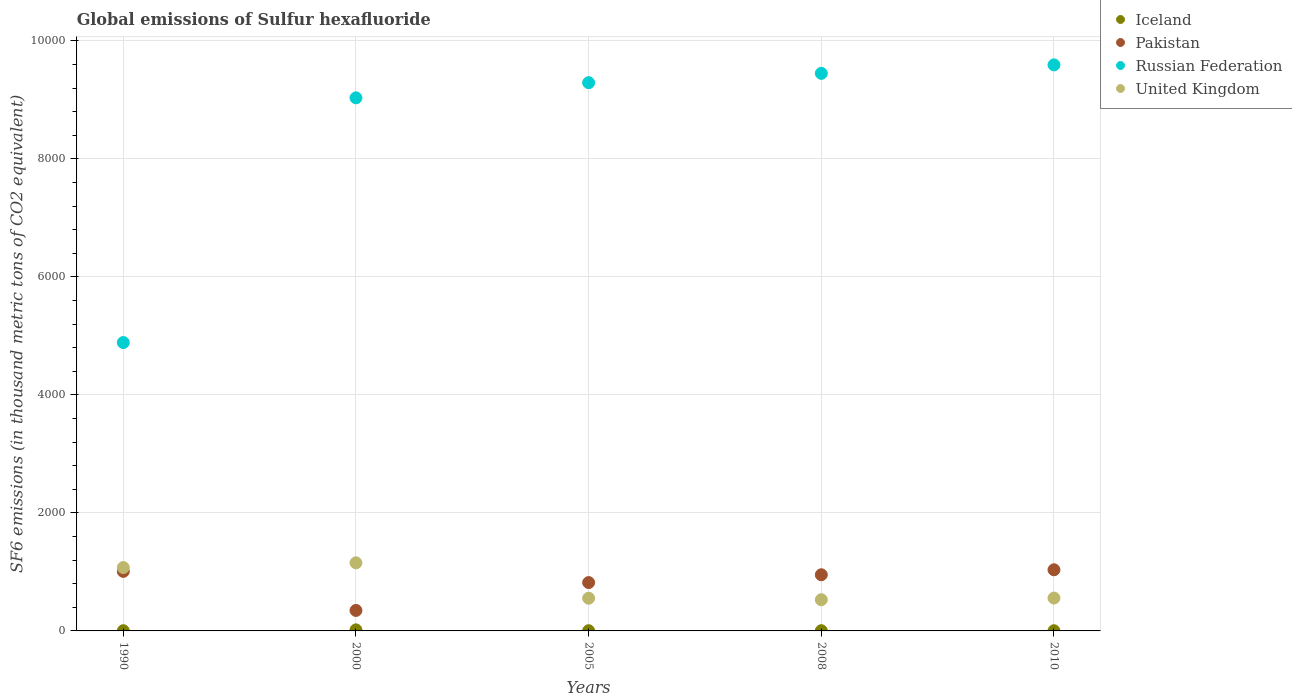Is the number of dotlines equal to the number of legend labels?
Provide a succinct answer. Yes. Across all years, what is the maximum global emissions of Sulfur hexafluoride in United Kingdom?
Offer a terse response. 1154.1. Across all years, what is the minimum global emissions of Sulfur hexafluoride in Russian Federation?
Ensure brevity in your answer.  4886.8. What is the total global emissions of Sulfur hexafluoride in United Kingdom in the graph?
Provide a succinct answer. 3868.1. What is the difference between the global emissions of Sulfur hexafluoride in United Kingdom in 2000 and that in 2008?
Provide a short and direct response. 625.2. What is the difference between the global emissions of Sulfur hexafluoride in Pakistan in 2000 and the global emissions of Sulfur hexafluoride in Russian Federation in 1990?
Make the answer very short. -4539.6. What is the average global emissions of Sulfur hexafluoride in United Kingdom per year?
Provide a short and direct response. 773.62. In the year 2005, what is the difference between the global emissions of Sulfur hexafluoride in Iceland and global emissions of Sulfur hexafluoride in Russian Federation?
Give a very brief answer. -9286.4. In how many years, is the global emissions of Sulfur hexafluoride in Iceland greater than 800 thousand metric tons?
Keep it short and to the point. 0. What is the ratio of the global emissions of Sulfur hexafluoride in United Kingdom in 2000 to that in 2005?
Make the answer very short. 2.08. Is the global emissions of Sulfur hexafluoride in Pakistan in 2005 less than that in 2008?
Make the answer very short. Yes. Is the difference between the global emissions of Sulfur hexafluoride in Iceland in 1990 and 2010 greater than the difference between the global emissions of Sulfur hexafluoride in Russian Federation in 1990 and 2010?
Offer a very short reply. Yes. What is the difference between the highest and the second highest global emissions of Sulfur hexafluoride in Iceland?
Offer a very short reply. 13.9. What is the difference between the highest and the lowest global emissions of Sulfur hexafluoride in Iceland?
Offer a very short reply. 14.9. Is the sum of the global emissions of Sulfur hexafluoride in Russian Federation in 2000 and 2008 greater than the maximum global emissions of Sulfur hexafluoride in Pakistan across all years?
Make the answer very short. Yes. Is it the case that in every year, the sum of the global emissions of Sulfur hexafluoride in Iceland and global emissions of Sulfur hexafluoride in Russian Federation  is greater than the sum of global emissions of Sulfur hexafluoride in United Kingdom and global emissions of Sulfur hexafluoride in Pakistan?
Your answer should be very brief. No. Is it the case that in every year, the sum of the global emissions of Sulfur hexafluoride in Iceland and global emissions of Sulfur hexafluoride in United Kingdom  is greater than the global emissions of Sulfur hexafluoride in Russian Federation?
Your response must be concise. No. Does the global emissions of Sulfur hexafluoride in Russian Federation monotonically increase over the years?
Provide a succinct answer. Yes. Is the global emissions of Sulfur hexafluoride in Iceland strictly greater than the global emissions of Sulfur hexafluoride in Pakistan over the years?
Provide a short and direct response. No. Is the global emissions of Sulfur hexafluoride in Russian Federation strictly less than the global emissions of Sulfur hexafluoride in Iceland over the years?
Offer a very short reply. No. How many dotlines are there?
Offer a terse response. 4. How many years are there in the graph?
Provide a short and direct response. 5. Does the graph contain grids?
Your answer should be compact. Yes. Where does the legend appear in the graph?
Provide a succinct answer. Top right. How are the legend labels stacked?
Ensure brevity in your answer.  Vertical. What is the title of the graph?
Your answer should be compact. Global emissions of Sulfur hexafluoride. What is the label or title of the X-axis?
Your response must be concise. Years. What is the label or title of the Y-axis?
Your answer should be compact. SF6 emissions (in thousand metric tons of CO2 equivalent). What is the SF6 emissions (in thousand metric tons of CO2 equivalent) in Pakistan in 1990?
Offer a terse response. 1009. What is the SF6 emissions (in thousand metric tons of CO2 equivalent) of Russian Federation in 1990?
Your answer should be very brief. 4886.8. What is the SF6 emissions (in thousand metric tons of CO2 equivalent) in United Kingdom in 1990?
Offer a terse response. 1073.9. What is the SF6 emissions (in thousand metric tons of CO2 equivalent) of Iceland in 2000?
Ensure brevity in your answer.  17.9. What is the SF6 emissions (in thousand metric tons of CO2 equivalent) in Pakistan in 2000?
Your answer should be compact. 347.2. What is the SF6 emissions (in thousand metric tons of CO2 equivalent) of Russian Federation in 2000?
Provide a short and direct response. 9033.2. What is the SF6 emissions (in thousand metric tons of CO2 equivalent) in United Kingdom in 2000?
Offer a terse response. 1154.1. What is the SF6 emissions (in thousand metric tons of CO2 equivalent) in Pakistan in 2005?
Make the answer very short. 819.4. What is the SF6 emissions (in thousand metric tons of CO2 equivalent) of Russian Federation in 2005?
Offer a very short reply. 9289.9. What is the SF6 emissions (in thousand metric tons of CO2 equivalent) in United Kingdom in 2005?
Give a very brief answer. 554.2. What is the SF6 emissions (in thousand metric tons of CO2 equivalent) of Iceland in 2008?
Keep it short and to the point. 4. What is the SF6 emissions (in thousand metric tons of CO2 equivalent) in Pakistan in 2008?
Make the answer very short. 951.6. What is the SF6 emissions (in thousand metric tons of CO2 equivalent) in Russian Federation in 2008?
Ensure brevity in your answer.  9448.2. What is the SF6 emissions (in thousand metric tons of CO2 equivalent) of United Kingdom in 2008?
Provide a short and direct response. 528.9. What is the SF6 emissions (in thousand metric tons of CO2 equivalent) of Pakistan in 2010?
Make the answer very short. 1036. What is the SF6 emissions (in thousand metric tons of CO2 equivalent) of Russian Federation in 2010?
Make the answer very short. 9592. What is the SF6 emissions (in thousand metric tons of CO2 equivalent) of United Kingdom in 2010?
Offer a very short reply. 557. Across all years, what is the maximum SF6 emissions (in thousand metric tons of CO2 equivalent) of Iceland?
Give a very brief answer. 17.9. Across all years, what is the maximum SF6 emissions (in thousand metric tons of CO2 equivalent) of Pakistan?
Offer a very short reply. 1036. Across all years, what is the maximum SF6 emissions (in thousand metric tons of CO2 equivalent) in Russian Federation?
Offer a terse response. 9592. Across all years, what is the maximum SF6 emissions (in thousand metric tons of CO2 equivalent) of United Kingdom?
Your response must be concise. 1154.1. Across all years, what is the minimum SF6 emissions (in thousand metric tons of CO2 equivalent) in Iceland?
Offer a terse response. 3. Across all years, what is the minimum SF6 emissions (in thousand metric tons of CO2 equivalent) of Pakistan?
Give a very brief answer. 347.2. Across all years, what is the minimum SF6 emissions (in thousand metric tons of CO2 equivalent) of Russian Federation?
Make the answer very short. 4886.8. Across all years, what is the minimum SF6 emissions (in thousand metric tons of CO2 equivalent) in United Kingdom?
Offer a terse response. 528.9. What is the total SF6 emissions (in thousand metric tons of CO2 equivalent) of Iceland in the graph?
Keep it short and to the point. 31.9. What is the total SF6 emissions (in thousand metric tons of CO2 equivalent) of Pakistan in the graph?
Your answer should be very brief. 4163.2. What is the total SF6 emissions (in thousand metric tons of CO2 equivalent) of Russian Federation in the graph?
Keep it short and to the point. 4.23e+04. What is the total SF6 emissions (in thousand metric tons of CO2 equivalent) of United Kingdom in the graph?
Your answer should be very brief. 3868.1. What is the difference between the SF6 emissions (in thousand metric tons of CO2 equivalent) of Iceland in 1990 and that in 2000?
Provide a succinct answer. -14.4. What is the difference between the SF6 emissions (in thousand metric tons of CO2 equivalent) in Pakistan in 1990 and that in 2000?
Your answer should be very brief. 661.8. What is the difference between the SF6 emissions (in thousand metric tons of CO2 equivalent) of Russian Federation in 1990 and that in 2000?
Provide a short and direct response. -4146.4. What is the difference between the SF6 emissions (in thousand metric tons of CO2 equivalent) of United Kingdom in 1990 and that in 2000?
Provide a succinct answer. -80.2. What is the difference between the SF6 emissions (in thousand metric tons of CO2 equivalent) in Iceland in 1990 and that in 2005?
Offer a very short reply. 0. What is the difference between the SF6 emissions (in thousand metric tons of CO2 equivalent) of Pakistan in 1990 and that in 2005?
Give a very brief answer. 189.6. What is the difference between the SF6 emissions (in thousand metric tons of CO2 equivalent) in Russian Federation in 1990 and that in 2005?
Provide a short and direct response. -4403.1. What is the difference between the SF6 emissions (in thousand metric tons of CO2 equivalent) of United Kingdom in 1990 and that in 2005?
Provide a succinct answer. 519.7. What is the difference between the SF6 emissions (in thousand metric tons of CO2 equivalent) of Iceland in 1990 and that in 2008?
Offer a very short reply. -0.5. What is the difference between the SF6 emissions (in thousand metric tons of CO2 equivalent) in Pakistan in 1990 and that in 2008?
Ensure brevity in your answer.  57.4. What is the difference between the SF6 emissions (in thousand metric tons of CO2 equivalent) of Russian Federation in 1990 and that in 2008?
Keep it short and to the point. -4561.4. What is the difference between the SF6 emissions (in thousand metric tons of CO2 equivalent) in United Kingdom in 1990 and that in 2008?
Offer a very short reply. 545. What is the difference between the SF6 emissions (in thousand metric tons of CO2 equivalent) of Iceland in 1990 and that in 2010?
Offer a very short reply. 0.5. What is the difference between the SF6 emissions (in thousand metric tons of CO2 equivalent) of Pakistan in 1990 and that in 2010?
Your answer should be very brief. -27. What is the difference between the SF6 emissions (in thousand metric tons of CO2 equivalent) of Russian Federation in 1990 and that in 2010?
Provide a short and direct response. -4705.2. What is the difference between the SF6 emissions (in thousand metric tons of CO2 equivalent) in United Kingdom in 1990 and that in 2010?
Provide a succinct answer. 516.9. What is the difference between the SF6 emissions (in thousand metric tons of CO2 equivalent) in Iceland in 2000 and that in 2005?
Your answer should be very brief. 14.4. What is the difference between the SF6 emissions (in thousand metric tons of CO2 equivalent) in Pakistan in 2000 and that in 2005?
Your answer should be compact. -472.2. What is the difference between the SF6 emissions (in thousand metric tons of CO2 equivalent) of Russian Federation in 2000 and that in 2005?
Make the answer very short. -256.7. What is the difference between the SF6 emissions (in thousand metric tons of CO2 equivalent) of United Kingdom in 2000 and that in 2005?
Give a very brief answer. 599.9. What is the difference between the SF6 emissions (in thousand metric tons of CO2 equivalent) in Iceland in 2000 and that in 2008?
Provide a short and direct response. 13.9. What is the difference between the SF6 emissions (in thousand metric tons of CO2 equivalent) in Pakistan in 2000 and that in 2008?
Provide a short and direct response. -604.4. What is the difference between the SF6 emissions (in thousand metric tons of CO2 equivalent) of Russian Federation in 2000 and that in 2008?
Your answer should be compact. -415. What is the difference between the SF6 emissions (in thousand metric tons of CO2 equivalent) of United Kingdom in 2000 and that in 2008?
Make the answer very short. 625.2. What is the difference between the SF6 emissions (in thousand metric tons of CO2 equivalent) of Pakistan in 2000 and that in 2010?
Your response must be concise. -688.8. What is the difference between the SF6 emissions (in thousand metric tons of CO2 equivalent) in Russian Federation in 2000 and that in 2010?
Give a very brief answer. -558.8. What is the difference between the SF6 emissions (in thousand metric tons of CO2 equivalent) in United Kingdom in 2000 and that in 2010?
Your answer should be compact. 597.1. What is the difference between the SF6 emissions (in thousand metric tons of CO2 equivalent) of Pakistan in 2005 and that in 2008?
Offer a very short reply. -132.2. What is the difference between the SF6 emissions (in thousand metric tons of CO2 equivalent) of Russian Federation in 2005 and that in 2008?
Offer a terse response. -158.3. What is the difference between the SF6 emissions (in thousand metric tons of CO2 equivalent) in United Kingdom in 2005 and that in 2008?
Make the answer very short. 25.3. What is the difference between the SF6 emissions (in thousand metric tons of CO2 equivalent) of Iceland in 2005 and that in 2010?
Ensure brevity in your answer.  0.5. What is the difference between the SF6 emissions (in thousand metric tons of CO2 equivalent) of Pakistan in 2005 and that in 2010?
Your response must be concise. -216.6. What is the difference between the SF6 emissions (in thousand metric tons of CO2 equivalent) of Russian Federation in 2005 and that in 2010?
Provide a succinct answer. -302.1. What is the difference between the SF6 emissions (in thousand metric tons of CO2 equivalent) in United Kingdom in 2005 and that in 2010?
Your response must be concise. -2.8. What is the difference between the SF6 emissions (in thousand metric tons of CO2 equivalent) of Pakistan in 2008 and that in 2010?
Your response must be concise. -84.4. What is the difference between the SF6 emissions (in thousand metric tons of CO2 equivalent) in Russian Federation in 2008 and that in 2010?
Make the answer very short. -143.8. What is the difference between the SF6 emissions (in thousand metric tons of CO2 equivalent) of United Kingdom in 2008 and that in 2010?
Offer a terse response. -28.1. What is the difference between the SF6 emissions (in thousand metric tons of CO2 equivalent) of Iceland in 1990 and the SF6 emissions (in thousand metric tons of CO2 equivalent) of Pakistan in 2000?
Keep it short and to the point. -343.7. What is the difference between the SF6 emissions (in thousand metric tons of CO2 equivalent) in Iceland in 1990 and the SF6 emissions (in thousand metric tons of CO2 equivalent) in Russian Federation in 2000?
Your answer should be very brief. -9029.7. What is the difference between the SF6 emissions (in thousand metric tons of CO2 equivalent) of Iceland in 1990 and the SF6 emissions (in thousand metric tons of CO2 equivalent) of United Kingdom in 2000?
Keep it short and to the point. -1150.6. What is the difference between the SF6 emissions (in thousand metric tons of CO2 equivalent) in Pakistan in 1990 and the SF6 emissions (in thousand metric tons of CO2 equivalent) in Russian Federation in 2000?
Your answer should be compact. -8024.2. What is the difference between the SF6 emissions (in thousand metric tons of CO2 equivalent) of Pakistan in 1990 and the SF6 emissions (in thousand metric tons of CO2 equivalent) of United Kingdom in 2000?
Provide a short and direct response. -145.1. What is the difference between the SF6 emissions (in thousand metric tons of CO2 equivalent) in Russian Federation in 1990 and the SF6 emissions (in thousand metric tons of CO2 equivalent) in United Kingdom in 2000?
Your answer should be compact. 3732.7. What is the difference between the SF6 emissions (in thousand metric tons of CO2 equivalent) of Iceland in 1990 and the SF6 emissions (in thousand metric tons of CO2 equivalent) of Pakistan in 2005?
Offer a terse response. -815.9. What is the difference between the SF6 emissions (in thousand metric tons of CO2 equivalent) of Iceland in 1990 and the SF6 emissions (in thousand metric tons of CO2 equivalent) of Russian Federation in 2005?
Your answer should be very brief. -9286.4. What is the difference between the SF6 emissions (in thousand metric tons of CO2 equivalent) in Iceland in 1990 and the SF6 emissions (in thousand metric tons of CO2 equivalent) in United Kingdom in 2005?
Offer a terse response. -550.7. What is the difference between the SF6 emissions (in thousand metric tons of CO2 equivalent) in Pakistan in 1990 and the SF6 emissions (in thousand metric tons of CO2 equivalent) in Russian Federation in 2005?
Offer a very short reply. -8280.9. What is the difference between the SF6 emissions (in thousand metric tons of CO2 equivalent) of Pakistan in 1990 and the SF6 emissions (in thousand metric tons of CO2 equivalent) of United Kingdom in 2005?
Give a very brief answer. 454.8. What is the difference between the SF6 emissions (in thousand metric tons of CO2 equivalent) in Russian Federation in 1990 and the SF6 emissions (in thousand metric tons of CO2 equivalent) in United Kingdom in 2005?
Your answer should be compact. 4332.6. What is the difference between the SF6 emissions (in thousand metric tons of CO2 equivalent) in Iceland in 1990 and the SF6 emissions (in thousand metric tons of CO2 equivalent) in Pakistan in 2008?
Give a very brief answer. -948.1. What is the difference between the SF6 emissions (in thousand metric tons of CO2 equivalent) of Iceland in 1990 and the SF6 emissions (in thousand metric tons of CO2 equivalent) of Russian Federation in 2008?
Your answer should be compact. -9444.7. What is the difference between the SF6 emissions (in thousand metric tons of CO2 equivalent) in Iceland in 1990 and the SF6 emissions (in thousand metric tons of CO2 equivalent) in United Kingdom in 2008?
Your answer should be very brief. -525.4. What is the difference between the SF6 emissions (in thousand metric tons of CO2 equivalent) in Pakistan in 1990 and the SF6 emissions (in thousand metric tons of CO2 equivalent) in Russian Federation in 2008?
Offer a very short reply. -8439.2. What is the difference between the SF6 emissions (in thousand metric tons of CO2 equivalent) in Pakistan in 1990 and the SF6 emissions (in thousand metric tons of CO2 equivalent) in United Kingdom in 2008?
Provide a short and direct response. 480.1. What is the difference between the SF6 emissions (in thousand metric tons of CO2 equivalent) of Russian Federation in 1990 and the SF6 emissions (in thousand metric tons of CO2 equivalent) of United Kingdom in 2008?
Ensure brevity in your answer.  4357.9. What is the difference between the SF6 emissions (in thousand metric tons of CO2 equivalent) in Iceland in 1990 and the SF6 emissions (in thousand metric tons of CO2 equivalent) in Pakistan in 2010?
Make the answer very short. -1032.5. What is the difference between the SF6 emissions (in thousand metric tons of CO2 equivalent) in Iceland in 1990 and the SF6 emissions (in thousand metric tons of CO2 equivalent) in Russian Federation in 2010?
Your response must be concise. -9588.5. What is the difference between the SF6 emissions (in thousand metric tons of CO2 equivalent) in Iceland in 1990 and the SF6 emissions (in thousand metric tons of CO2 equivalent) in United Kingdom in 2010?
Offer a very short reply. -553.5. What is the difference between the SF6 emissions (in thousand metric tons of CO2 equivalent) of Pakistan in 1990 and the SF6 emissions (in thousand metric tons of CO2 equivalent) of Russian Federation in 2010?
Your answer should be very brief. -8583. What is the difference between the SF6 emissions (in thousand metric tons of CO2 equivalent) in Pakistan in 1990 and the SF6 emissions (in thousand metric tons of CO2 equivalent) in United Kingdom in 2010?
Make the answer very short. 452. What is the difference between the SF6 emissions (in thousand metric tons of CO2 equivalent) in Russian Federation in 1990 and the SF6 emissions (in thousand metric tons of CO2 equivalent) in United Kingdom in 2010?
Ensure brevity in your answer.  4329.8. What is the difference between the SF6 emissions (in thousand metric tons of CO2 equivalent) of Iceland in 2000 and the SF6 emissions (in thousand metric tons of CO2 equivalent) of Pakistan in 2005?
Your answer should be very brief. -801.5. What is the difference between the SF6 emissions (in thousand metric tons of CO2 equivalent) in Iceland in 2000 and the SF6 emissions (in thousand metric tons of CO2 equivalent) in Russian Federation in 2005?
Your response must be concise. -9272. What is the difference between the SF6 emissions (in thousand metric tons of CO2 equivalent) of Iceland in 2000 and the SF6 emissions (in thousand metric tons of CO2 equivalent) of United Kingdom in 2005?
Make the answer very short. -536.3. What is the difference between the SF6 emissions (in thousand metric tons of CO2 equivalent) of Pakistan in 2000 and the SF6 emissions (in thousand metric tons of CO2 equivalent) of Russian Federation in 2005?
Your answer should be very brief. -8942.7. What is the difference between the SF6 emissions (in thousand metric tons of CO2 equivalent) of Pakistan in 2000 and the SF6 emissions (in thousand metric tons of CO2 equivalent) of United Kingdom in 2005?
Offer a very short reply. -207. What is the difference between the SF6 emissions (in thousand metric tons of CO2 equivalent) in Russian Federation in 2000 and the SF6 emissions (in thousand metric tons of CO2 equivalent) in United Kingdom in 2005?
Your response must be concise. 8479. What is the difference between the SF6 emissions (in thousand metric tons of CO2 equivalent) in Iceland in 2000 and the SF6 emissions (in thousand metric tons of CO2 equivalent) in Pakistan in 2008?
Your response must be concise. -933.7. What is the difference between the SF6 emissions (in thousand metric tons of CO2 equivalent) of Iceland in 2000 and the SF6 emissions (in thousand metric tons of CO2 equivalent) of Russian Federation in 2008?
Ensure brevity in your answer.  -9430.3. What is the difference between the SF6 emissions (in thousand metric tons of CO2 equivalent) of Iceland in 2000 and the SF6 emissions (in thousand metric tons of CO2 equivalent) of United Kingdom in 2008?
Make the answer very short. -511. What is the difference between the SF6 emissions (in thousand metric tons of CO2 equivalent) of Pakistan in 2000 and the SF6 emissions (in thousand metric tons of CO2 equivalent) of Russian Federation in 2008?
Keep it short and to the point. -9101. What is the difference between the SF6 emissions (in thousand metric tons of CO2 equivalent) in Pakistan in 2000 and the SF6 emissions (in thousand metric tons of CO2 equivalent) in United Kingdom in 2008?
Offer a very short reply. -181.7. What is the difference between the SF6 emissions (in thousand metric tons of CO2 equivalent) of Russian Federation in 2000 and the SF6 emissions (in thousand metric tons of CO2 equivalent) of United Kingdom in 2008?
Ensure brevity in your answer.  8504.3. What is the difference between the SF6 emissions (in thousand metric tons of CO2 equivalent) in Iceland in 2000 and the SF6 emissions (in thousand metric tons of CO2 equivalent) in Pakistan in 2010?
Your answer should be very brief. -1018.1. What is the difference between the SF6 emissions (in thousand metric tons of CO2 equivalent) in Iceland in 2000 and the SF6 emissions (in thousand metric tons of CO2 equivalent) in Russian Federation in 2010?
Ensure brevity in your answer.  -9574.1. What is the difference between the SF6 emissions (in thousand metric tons of CO2 equivalent) in Iceland in 2000 and the SF6 emissions (in thousand metric tons of CO2 equivalent) in United Kingdom in 2010?
Your response must be concise. -539.1. What is the difference between the SF6 emissions (in thousand metric tons of CO2 equivalent) of Pakistan in 2000 and the SF6 emissions (in thousand metric tons of CO2 equivalent) of Russian Federation in 2010?
Provide a short and direct response. -9244.8. What is the difference between the SF6 emissions (in thousand metric tons of CO2 equivalent) in Pakistan in 2000 and the SF6 emissions (in thousand metric tons of CO2 equivalent) in United Kingdom in 2010?
Your response must be concise. -209.8. What is the difference between the SF6 emissions (in thousand metric tons of CO2 equivalent) of Russian Federation in 2000 and the SF6 emissions (in thousand metric tons of CO2 equivalent) of United Kingdom in 2010?
Offer a terse response. 8476.2. What is the difference between the SF6 emissions (in thousand metric tons of CO2 equivalent) of Iceland in 2005 and the SF6 emissions (in thousand metric tons of CO2 equivalent) of Pakistan in 2008?
Make the answer very short. -948.1. What is the difference between the SF6 emissions (in thousand metric tons of CO2 equivalent) in Iceland in 2005 and the SF6 emissions (in thousand metric tons of CO2 equivalent) in Russian Federation in 2008?
Provide a succinct answer. -9444.7. What is the difference between the SF6 emissions (in thousand metric tons of CO2 equivalent) in Iceland in 2005 and the SF6 emissions (in thousand metric tons of CO2 equivalent) in United Kingdom in 2008?
Keep it short and to the point. -525.4. What is the difference between the SF6 emissions (in thousand metric tons of CO2 equivalent) in Pakistan in 2005 and the SF6 emissions (in thousand metric tons of CO2 equivalent) in Russian Federation in 2008?
Provide a short and direct response. -8628.8. What is the difference between the SF6 emissions (in thousand metric tons of CO2 equivalent) in Pakistan in 2005 and the SF6 emissions (in thousand metric tons of CO2 equivalent) in United Kingdom in 2008?
Give a very brief answer. 290.5. What is the difference between the SF6 emissions (in thousand metric tons of CO2 equivalent) of Russian Federation in 2005 and the SF6 emissions (in thousand metric tons of CO2 equivalent) of United Kingdom in 2008?
Ensure brevity in your answer.  8761. What is the difference between the SF6 emissions (in thousand metric tons of CO2 equivalent) in Iceland in 2005 and the SF6 emissions (in thousand metric tons of CO2 equivalent) in Pakistan in 2010?
Offer a very short reply. -1032.5. What is the difference between the SF6 emissions (in thousand metric tons of CO2 equivalent) of Iceland in 2005 and the SF6 emissions (in thousand metric tons of CO2 equivalent) of Russian Federation in 2010?
Your answer should be compact. -9588.5. What is the difference between the SF6 emissions (in thousand metric tons of CO2 equivalent) of Iceland in 2005 and the SF6 emissions (in thousand metric tons of CO2 equivalent) of United Kingdom in 2010?
Offer a very short reply. -553.5. What is the difference between the SF6 emissions (in thousand metric tons of CO2 equivalent) of Pakistan in 2005 and the SF6 emissions (in thousand metric tons of CO2 equivalent) of Russian Federation in 2010?
Keep it short and to the point. -8772.6. What is the difference between the SF6 emissions (in thousand metric tons of CO2 equivalent) of Pakistan in 2005 and the SF6 emissions (in thousand metric tons of CO2 equivalent) of United Kingdom in 2010?
Keep it short and to the point. 262.4. What is the difference between the SF6 emissions (in thousand metric tons of CO2 equivalent) of Russian Federation in 2005 and the SF6 emissions (in thousand metric tons of CO2 equivalent) of United Kingdom in 2010?
Keep it short and to the point. 8732.9. What is the difference between the SF6 emissions (in thousand metric tons of CO2 equivalent) in Iceland in 2008 and the SF6 emissions (in thousand metric tons of CO2 equivalent) in Pakistan in 2010?
Provide a succinct answer. -1032. What is the difference between the SF6 emissions (in thousand metric tons of CO2 equivalent) of Iceland in 2008 and the SF6 emissions (in thousand metric tons of CO2 equivalent) of Russian Federation in 2010?
Your answer should be compact. -9588. What is the difference between the SF6 emissions (in thousand metric tons of CO2 equivalent) of Iceland in 2008 and the SF6 emissions (in thousand metric tons of CO2 equivalent) of United Kingdom in 2010?
Offer a very short reply. -553. What is the difference between the SF6 emissions (in thousand metric tons of CO2 equivalent) of Pakistan in 2008 and the SF6 emissions (in thousand metric tons of CO2 equivalent) of Russian Federation in 2010?
Make the answer very short. -8640.4. What is the difference between the SF6 emissions (in thousand metric tons of CO2 equivalent) in Pakistan in 2008 and the SF6 emissions (in thousand metric tons of CO2 equivalent) in United Kingdom in 2010?
Give a very brief answer. 394.6. What is the difference between the SF6 emissions (in thousand metric tons of CO2 equivalent) of Russian Federation in 2008 and the SF6 emissions (in thousand metric tons of CO2 equivalent) of United Kingdom in 2010?
Offer a terse response. 8891.2. What is the average SF6 emissions (in thousand metric tons of CO2 equivalent) in Iceland per year?
Offer a very short reply. 6.38. What is the average SF6 emissions (in thousand metric tons of CO2 equivalent) in Pakistan per year?
Provide a succinct answer. 832.64. What is the average SF6 emissions (in thousand metric tons of CO2 equivalent) of Russian Federation per year?
Offer a terse response. 8450.02. What is the average SF6 emissions (in thousand metric tons of CO2 equivalent) of United Kingdom per year?
Offer a very short reply. 773.62. In the year 1990, what is the difference between the SF6 emissions (in thousand metric tons of CO2 equivalent) in Iceland and SF6 emissions (in thousand metric tons of CO2 equivalent) in Pakistan?
Provide a succinct answer. -1005.5. In the year 1990, what is the difference between the SF6 emissions (in thousand metric tons of CO2 equivalent) of Iceland and SF6 emissions (in thousand metric tons of CO2 equivalent) of Russian Federation?
Your response must be concise. -4883.3. In the year 1990, what is the difference between the SF6 emissions (in thousand metric tons of CO2 equivalent) in Iceland and SF6 emissions (in thousand metric tons of CO2 equivalent) in United Kingdom?
Offer a very short reply. -1070.4. In the year 1990, what is the difference between the SF6 emissions (in thousand metric tons of CO2 equivalent) of Pakistan and SF6 emissions (in thousand metric tons of CO2 equivalent) of Russian Federation?
Offer a terse response. -3877.8. In the year 1990, what is the difference between the SF6 emissions (in thousand metric tons of CO2 equivalent) of Pakistan and SF6 emissions (in thousand metric tons of CO2 equivalent) of United Kingdom?
Provide a succinct answer. -64.9. In the year 1990, what is the difference between the SF6 emissions (in thousand metric tons of CO2 equivalent) of Russian Federation and SF6 emissions (in thousand metric tons of CO2 equivalent) of United Kingdom?
Your answer should be compact. 3812.9. In the year 2000, what is the difference between the SF6 emissions (in thousand metric tons of CO2 equivalent) in Iceland and SF6 emissions (in thousand metric tons of CO2 equivalent) in Pakistan?
Your answer should be very brief. -329.3. In the year 2000, what is the difference between the SF6 emissions (in thousand metric tons of CO2 equivalent) of Iceland and SF6 emissions (in thousand metric tons of CO2 equivalent) of Russian Federation?
Keep it short and to the point. -9015.3. In the year 2000, what is the difference between the SF6 emissions (in thousand metric tons of CO2 equivalent) in Iceland and SF6 emissions (in thousand metric tons of CO2 equivalent) in United Kingdom?
Your response must be concise. -1136.2. In the year 2000, what is the difference between the SF6 emissions (in thousand metric tons of CO2 equivalent) of Pakistan and SF6 emissions (in thousand metric tons of CO2 equivalent) of Russian Federation?
Ensure brevity in your answer.  -8686. In the year 2000, what is the difference between the SF6 emissions (in thousand metric tons of CO2 equivalent) in Pakistan and SF6 emissions (in thousand metric tons of CO2 equivalent) in United Kingdom?
Provide a succinct answer. -806.9. In the year 2000, what is the difference between the SF6 emissions (in thousand metric tons of CO2 equivalent) in Russian Federation and SF6 emissions (in thousand metric tons of CO2 equivalent) in United Kingdom?
Provide a short and direct response. 7879.1. In the year 2005, what is the difference between the SF6 emissions (in thousand metric tons of CO2 equivalent) of Iceland and SF6 emissions (in thousand metric tons of CO2 equivalent) of Pakistan?
Make the answer very short. -815.9. In the year 2005, what is the difference between the SF6 emissions (in thousand metric tons of CO2 equivalent) of Iceland and SF6 emissions (in thousand metric tons of CO2 equivalent) of Russian Federation?
Offer a very short reply. -9286.4. In the year 2005, what is the difference between the SF6 emissions (in thousand metric tons of CO2 equivalent) of Iceland and SF6 emissions (in thousand metric tons of CO2 equivalent) of United Kingdom?
Your response must be concise. -550.7. In the year 2005, what is the difference between the SF6 emissions (in thousand metric tons of CO2 equivalent) of Pakistan and SF6 emissions (in thousand metric tons of CO2 equivalent) of Russian Federation?
Provide a succinct answer. -8470.5. In the year 2005, what is the difference between the SF6 emissions (in thousand metric tons of CO2 equivalent) in Pakistan and SF6 emissions (in thousand metric tons of CO2 equivalent) in United Kingdom?
Provide a succinct answer. 265.2. In the year 2005, what is the difference between the SF6 emissions (in thousand metric tons of CO2 equivalent) of Russian Federation and SF6 emissions (in thousand metric tons of CO2 equivalent) of United Kingdom?
Your answer should be compact. 8735.7. In the year 2008, what is the difference between the SF6 emissions (in thousand metric tons of CO2 equivalent) of Iceland and SF6 emissions (in thousand metric tons of CO2 equivalent) of Pakistan?
Ensure brevity in your answer.  -947.6. In the year 2008, what is the difference between the SF6 emissions (in thousand metric tons of CO2 equivalent) in Iceland and SF6 emissions (in thousand metric tons of CO2 equivalent) in Russian Federation?
Give a very brief answer. -9444.2. In the year 2008, what is the difference between the SF6 emissions (in thousand metric tons of CO2 equivalent) in Iceland and SF6 emissions (in thousand metric tons of CO2 equivalent) in United Kingdom?
Give a very brief answer. -524.9. In the year 2008, what is the difference between the SF6 emissions (in thousand metric tons of CO2 equivalent) in Pakistan and SF6 emissions (in thousand metric tons of CO2 equivalent) in Russian Federation?
Provide a short and direct response. -8496.6. In the year 2008, what is the difference between the SF6 emissions (in thousand metric tons of CO2 equivalent) of Pakistan and SF6 emissions (in thousand metric tons of CO2 equivalent) of United Kingdom?
Offer a terse response. 422.7. In the year 2008, what is the difference between the SF6 emissions (in thousand metric tons of CO2 equivalent) of Russian Federation and SF6 emissions (in thousand metric tons of CO2 equivalent) of United Kingdom?
Offer a very short reply. 8919.3. In the year 2010, what is the difference between the SF6 emissions (in thousand metric tons of CO2 equivalent) in Iceland and SF6 emissions (in thousand metric tons of CO2 equivalent) in Pakistan?
Your answer should be compact. -1033. In the year 2010, what is the difference between the SF6 emissions (in thousand metric tons of CO2 equivalent) of Iceland and SF6 emissions (in thousand metric tons of CO2 equivalent) of Russian Federation?
Give a very brief answer. -9589. In the year 2010, what is the difference between the SF6 emissions (in thousand metric tons of CO2 equivalent) of Iceland and SF6 emissions (in thousand metric tons of CO2 equivalent) of United Kingdom?
Give a very brief answer. -554. In the year 2010, what is the difference between the SF6 emissions (in thousand metric tons of CO2 equivalent) in Pakistan and SF6 emissions (in thousand metric tons of CO2 equivalent) in Russian Federation?
Your answer should be compact. -8556. In the year 2010, what is the difference between the SF6 emissions (in thousand metric tons of CO2 equivalent) in Pakistan and SF6 emissions (in thousand metric tons of CO2 equivalent) in United Kingdom?
Keep it short and to the point. 479. In the year 2010, what is the difference between the SF6 emissions (in thousand metric tons of CO2 equivalent) in Russian Federation and SF6 emissions (in thousand metric tons of CO2 equivalent) in United Kingdom?
Keep it short and to the point. 9035. What is the ratio of the SF6 emissions (in thousand metric tons of CO2 equivalent) of Iceland in 1990 to that in 2000?
Your answer should be very brief. 0.2. What is the ratio of the SF6 emissions (in thousand metric tons of CO2 equivalent) of Pakistan in 1990 to that in 2000?
Your answer should be very brief. 2.91. What is the ratio of the SF6 emissions (in thousand metric tons of CO2 equivalent) in Russian Federation in 1990 to that in 2000?
Your answer should be very brief. 0.54. What is the ratio of the SF6 emissions (in thousand metric tons of CO2 equivalent) in United Kingdom in 1990 to that in 2000?
Ensure brevity in your answer.  0.93. What is the ratio of the SF6 emissions (in thousand metric tons of CO2 equivalent) of Iceland in 1990 to that in 2005?
Provide a succinct answer. 1. What is the ratio of the SF6 emissions (in thousand metric tons of CO2 equivalent) of Pakistan in 1990 to that in 2005?
Keep it short and to the point. 1.23. What is the ratio of the SF6 emissions (in thousand metric tons of CO2 equivalent) in Russian Federation in 1990 to that in 2005?
Offer a very short reply. 0.53. What is the ratio of the SF6 emissions (in thousand metric tons of CO2 equivalent) of United Kingdom in 1990 to that in 2005?
Your response must be concise. 1.94. What is the ratio of the SF6 emissions (in thousand metric tons of CO2 equivalent) in Iceland in 1990 to that in 2008?
Your answer should be compact. 0.88. What is the ratio of the SF6 emissions (in thousand metric tons of CO2 equivalent) of Pakistan in 1990 to that in 2008?
Ensure brevity in your answer.  1.06. What is the ratio of the SF6 emissions (in thousand metric tons of CO2 equivalent) in Russian Federation in 1990 to that in 2008?
Your answer should be compact. 0.52. What is the ratio of the SF6 emissions (in thousand metric tons of CO2 equivalent) of United Kingdom in 1990 to that in 2008?
Provide a short and direct response. 2.03. What is the ratio of the SF6 emissions (in thousand metric tons of CO2 equivalent) of Iceland in 1990 to that in 2010?
Provide a succinct answer. 1.17. What is the ratio of the SF6 emissions (in thousand metric tons of CO2 equivalent) of Pakistan in 1990 to that in 2010?
Ensure brevity in your answer.  0.97. What is the ratio of the SF6 emissions (in thousand metric tons of CO2 equivalent) in Russian Federation in 1990 to that in 2010?
Offer a terse response. 0.51. What is the ratio of the SF6 emissions (in thousand metric tons of CO2 equivalent) in United Kingdom in 1990 to that in 2010?
Your answer should be compact. 1.93. What is the ratio of the SF6 emissions (in thousand metric tons of CO2 equivalent) in Iceland in 2000 to that in 2005?
Your answer should be compact. 5.11. What is the ratio of the SF6 emissions (in thousand metric tons of CO2 equivalent) in Pakistan in 2000 to that in 2005?
Your answer should be very brief. 0.42. What is the ratio of the SF6 emissions (in thousand metric tons of CO2 equivalent) of Russian Federation in 2000 to that in 2005?
Ensure brevity in your answer.  0.97. What is the ratio of the SF6 emissions (in thousand metric tons of CO2 equivalent) in United Kingdom in 2000 to that in 2005?
Ensure brevity in your answer.  2.08. What is the ratio of the SF6 emissions (in thousand metric tons of CO2 equivalent) of Iceland in 2000 to that in 2008?
Make the answer very short. 4.47. What is the ratio of the SF6 emissions (in thousand metric tons of CO2 equivalent) of Pakistan in 2000 to that in 2008?
Make the answer very short. 0.36. What is the ratio of the SF6 emissions (in thousand metric tons of CO2 equivalent) in Russian Federation in 2000 to that in 2008?
Ensure brevity in your answer.  0.96. What is the ratio of the SF6 emissions (in thousand metric tons of CO2 equivalent) of United Kingdom in 2000 to that in 2008?
Offer a very short reply. 2.18. What is the ratio of the SF6 emissions (in thousand metric tons of CO2 equivalent) in Iceland in 2000 to that in 2010?
Ensure brevity in your answer.  5.97. What is the ratio of the SF6 emissions (in thousand metric tons of CO2 equivalent) in Pakistan in 2000 to that in 2010?
Offer a very short reply. 0.34. What is the ratio of the SF6 emissions (in thousand metric tons of CO2 equivalent) in Russian Federation in 2000 to that in 2010?
Offer a very short reply. 0.94. What is the ratio of the SF6 emissions (in thousand metric tons of CO2 equivalent) of United Kingdom in 2000 to that in 2010?
Keep it short and to the point. 2.07. What is the ratio of the SF6 emissions (in thousand metric tons of CO2 equivalent) of Pakistan in 2005 to that in 2008?
Offer a terse response. 0.86. What is the ratio of the SF6 emissions (in thousand metric tons of CO2 equivalent) in Russian Federation in 2005 to that in 2008?
Your answer should be compact. 0.98. What is the ratio of the SF6 emissions (in thousand metric tons of CO2 equivalent) of United Kingdom in 2005 to that in 2008?
Ensure brevity in your answer.  1.05. What is the ratio of the SF6 emissions (in thousand metric tons of CO2 equivalent) in Iceland in 2005 to that in 2010?
Make the answer very short. 1.17. What is the ratio of the SF6 emissions (in thousand metric tons of CO2 equivalent) of Pakistan in 2005 to that in 2010?
Ensure brevity in your answer.  0.79. What is the ratio of the SF6 emissions (in thousand metric tons of CO2 equivalent) of Russian Federation in 2005 to that in 2010?
Your answer should be very brief. 0.97. What is the ratio of the SF6 emissions (in thousand metric tons of CO2 equivalent) in United Kingdom in 2005 to that in 2010?
Keep it short and to the point. 0.99. What is the ratio of the SF6 emissions (in thousand metric tons of CO2 equivalent) of Iceland in 2008 to that in 2010?
Keep it short and to the point. 1.33. What is the ratio of the SF6 emissions (in thousand metric tons of CO2 equivalent) of Pakistan in 2008 to that in 2010?
Make the answer very short. 0.92. What is the ratio of the SF6 emissions (in thousand metric tons of CO2 equivalent) in Russian Federation in 2008 to that in 2010?
Offer a terse response. 0.98. What is the ratio of the SF6 emissions (in thousand metric tons of CO2 equivalent) of United Kingdom in 2008 to that in 2010?
Provide a short and direct response. 0.95. What is the difference between the highest and the second highest SF6 emissions (in thousand metric tons of CO2 equivalent) in Pakistan?
Give a very brief answer. 27. What is the difference between the highest and the second highest SF6 emissions (in thousand metric tons of CO2 equivalent) in Russian Federation?
Keep it short and to the point. 143.8. What is the difference between the highest and the second highest SF6 emissions (in thousand metric tons of CO2 equivalent) in United Kingdom?
Your answer should be compact. 80.2. What is the difference between the highest and the lowest SF6 emissions (in thousand metric tons of CO2 equivalent) of Iceland?
Your answer should be compact. 14.9. What is the difference between the highest and the lowest SF6 emissions (in thousand metric tons of CO2 equivalent) in Pakistan?
Offer a terse response. 688.8. What is the difference between the highest and the lowest SF6 emissions (in thousand metric tons of CO2 equivalent) of Russian Federation?
Keep it short and to the point. 4705.2. What is the difference between the highest and the lowest SF6 emissions (in thousand metric tons of CO2 equivalent) of United Kingdom?
Offer a very short reply. 625.2. 